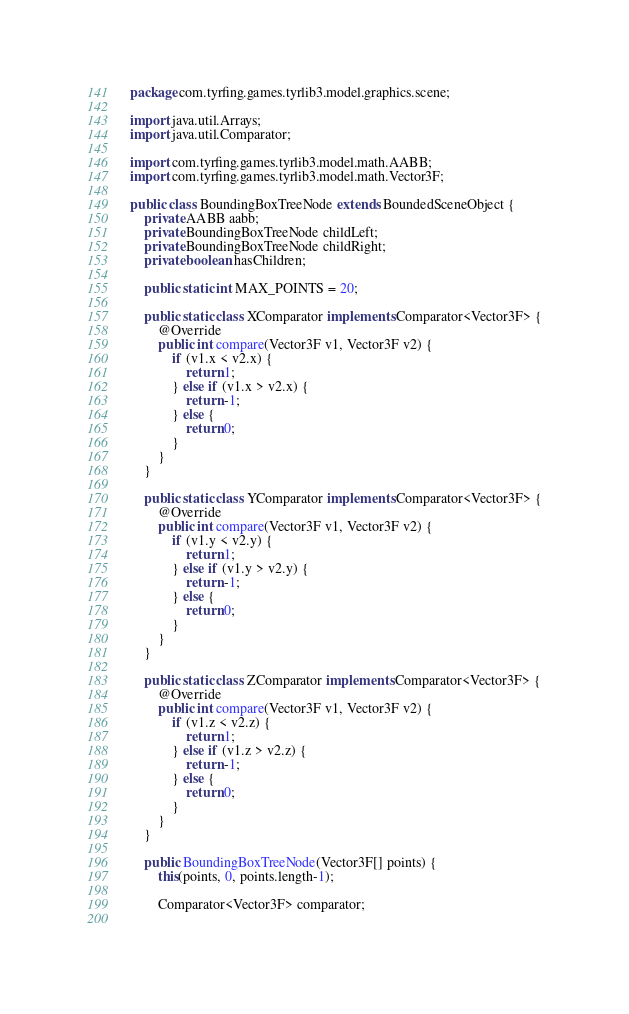<code> <loc_0><loc_0><loc_500><loc_500><_Java_>package com.tyrfing.games.tyrlib3.model.graphics.scene;

import java.util.Arrays;
import java.util.Comparator;

import com.tyrfing.games.tyrlib3.model.math.AABB;
import com.tyrfing.games.tyrlib3.model.math.Vector3F;

public class BoundingBoxTreeNode extends BoundedSceneObject {
	private AABB aabb;
	private BoundingBoxTreeNode childLeft;
	private BoundingBoxTreeNode childRight;
	private boolean hasChildren;
	
	public static int MAX_POINTS = 20;
	
	public static class XComparator implements Comparator<Vector3F> {
		@Override
		public int compare(Vector3F v1, Vector3F v2) {
			if (v1.x < v2.x) {
				return 1;
			} else if (v1.x > v2.x) {
				return -1;
			} else {
				return 0;
			}
		}
	}
	
	public static class YComparator implements Comparator<Vector3F> {
		@Override
		public int compare(Vector3F v1, Vector3F v2) {
			if (v1.y < v2.y) {
				return 1;
			} else if (v1.y > v2.y) {
				return -1;
			} else {
				return 0;
			}
		}
	}
	
	public static class ZComparator implements Comparator<Vector3F> {
		@Override
		public int compare(Vector3F v1, Vector3F v2) {
			if (v1.z < v2.z) {
				return 1;
			} else if (v1.z > v2.z) {
				return -1;
			} else {
				return 0;
			}
		}
	}
	
	public BoundingBoxTreeNode(Vector3F[] points) {
		this(points, 0, points.length-1);

		Comparator<Vector3F> comparator;
			</code> 